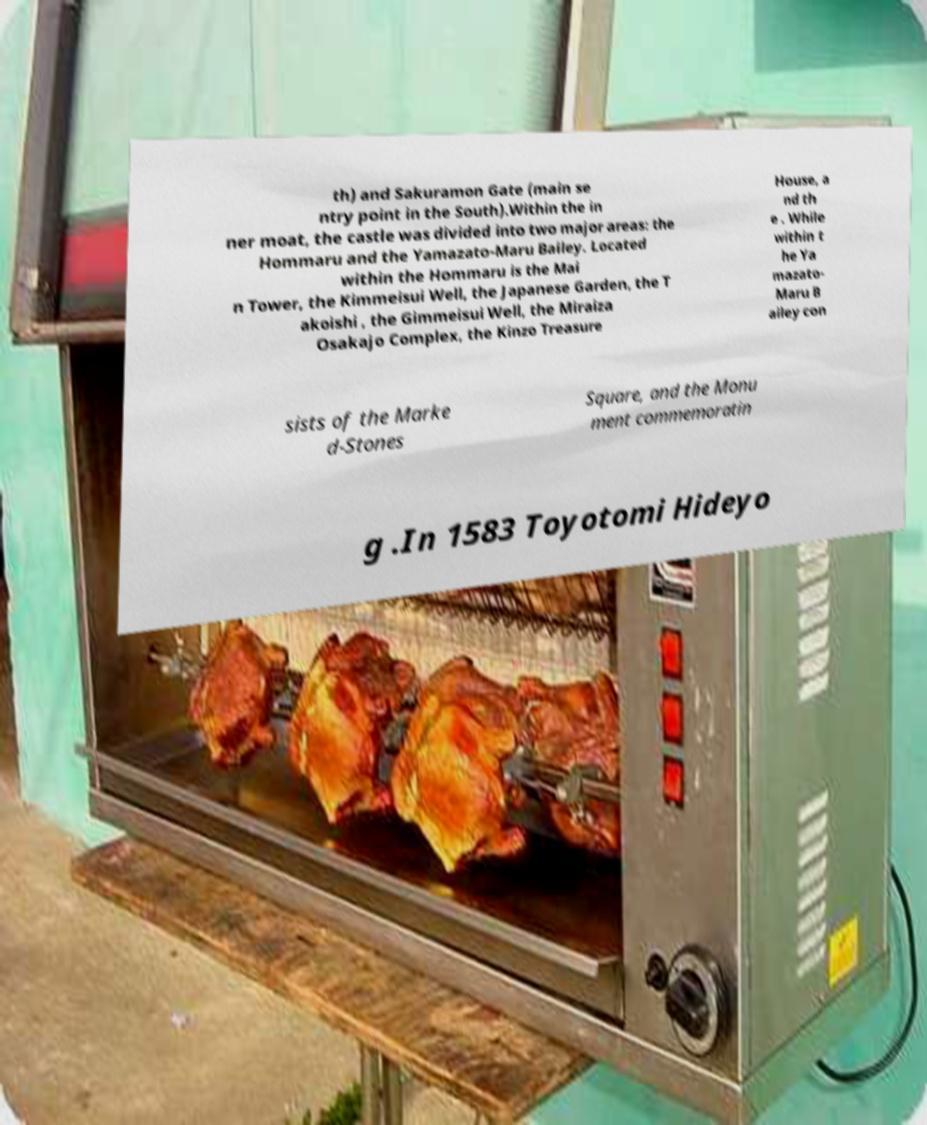Can you accurately transcribe the text from the provided image for me? th) and Sakuramon Gate (main se ntry point in the South).Within the in ner moat, the castle was divided into two major areas: the Hommaru and the Yamazato-Maru Bailey. Located within the Hommaru is the Mai n Tower, the Kimmeisui Well, the Japanese Garden, the T akoishi , the Gimmeisui Well, the Miraiza Osakajo Complex, the Kinzo Treasure House, a nd th e . While within t he Ya mazato- Maru B ailey con sists of the Marke d-Stones Square, and the Monu ment commemoratin g .In 1583 Toyotomi Hideyo 